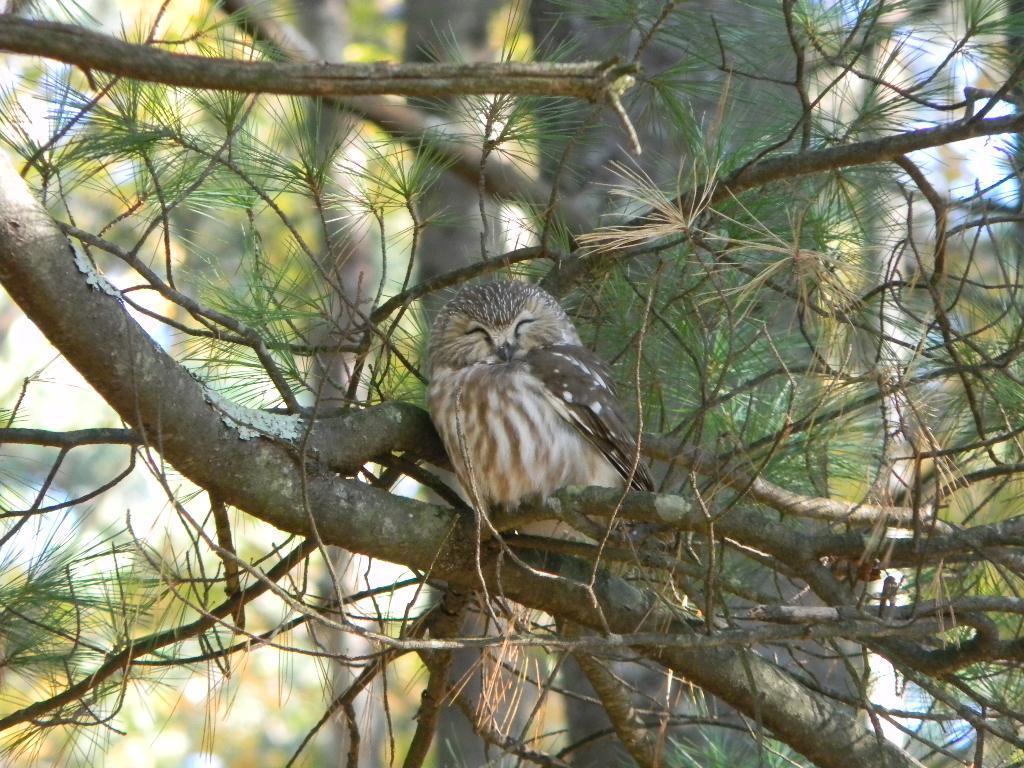Can you describe this image briefly? In the middle of the picture, we see the bird is on the tree and this bird looks like an owl. In the background, there are trees. 